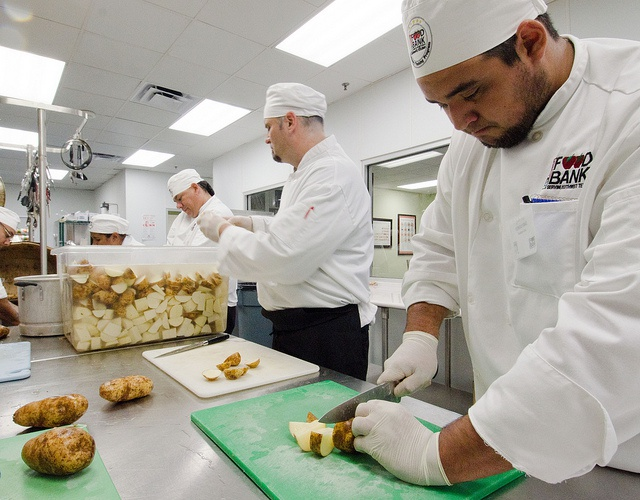Describe the objects in this image and their specific colors. I can see people in darkgray and lightgray tones, people in darkgray, lightgray, black, and gray tones, bowl in darkgray, tan, lightgray, and olive tones, people in darkgray, lightgray, salmon, and tan tones, and people in darkgray, lightgray, maroon, and brown tones in this image. 